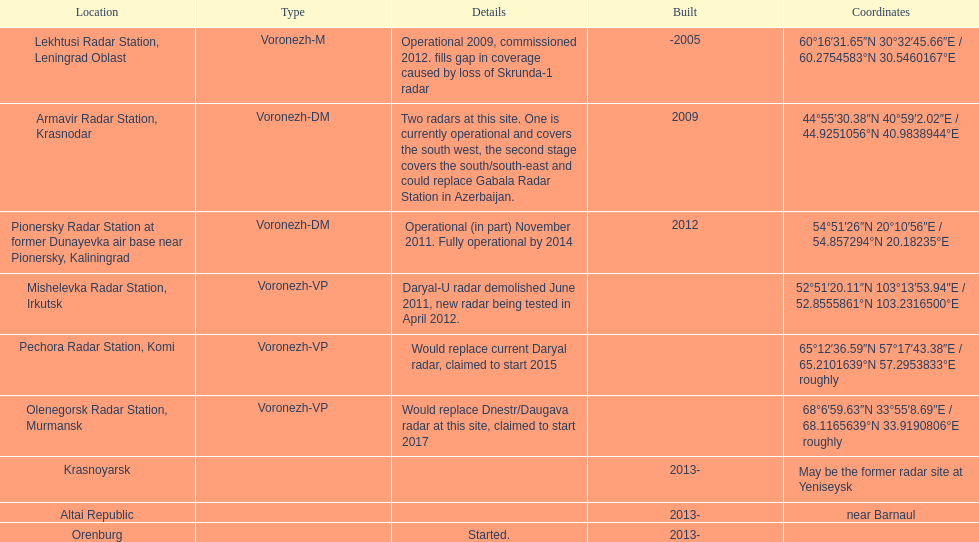What year built is at the top? -2005. 